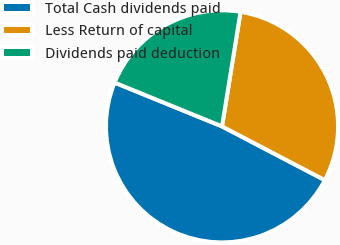<chart> <loc_0><loc_0><loc_500><loc_500><pie_chart><fcel>Total Cash dividends paid<fcel>Less Return of capital<fcel>Dividends paid deduction<nl><fcel>48.49%<fcel>30.12%<fcel>21.39%<nl></chart> 